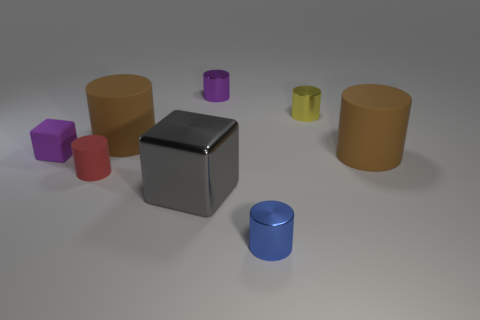There is a small purple metal thing; is its shape the same as the big object to the left of the gray thing?
Provide a succinct answer. Yes. Is the number of purple blocks behind the purple matte cube the same as the number of big matte cylinders that are to the right of the gray metallic block?
Offer a very short reply. No. How many other things are made of the same material as the small purple cylinder?
Make the answer very short. 3. What number of matte objects are either large gray things or large brown cylinders?
Offer a very short reply. 2. Do the large brown object that is in front of the small block and the red object have the same shape?
Give a very brief answer. Yes. Is the number of big matte cylinders that are on the right side of the big gray block greater than the number of large gray matte cylinders?
Provide a short and direct response. Yes. How many things are right of the large gray metal cube and behind the small purple matte block?
Your answer should be very brief. 2. What color is the cube to the left of the matte cylinder behind the tiny purple matte thing?
Ensure brevity in your answer.  Purple. How many metal objects are the same color as the small rubber block?
Your answer should be compact. 1. There is a matte block; is its color the same as the small cylinder that is behind the small yellow metal cylinder?
Offer a very short reply. Yes. 